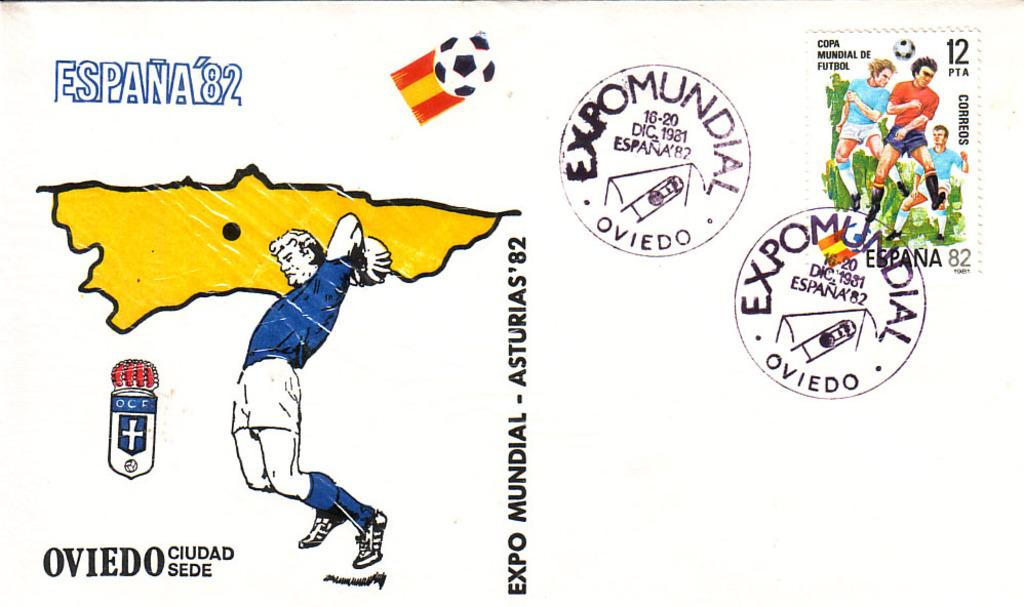What is the main object in the image? There is a poster in the image. What can be seen on the left side of the poster? There is a cartoon image of a person on the left side of the poster. What other elements are present on the poster? There are stamps, a logo, a picture of persons, and text on the poster. Can you tell me the purpose of the giraffe in the image? There is no giraffe present in the image, so it is not possible to determine its purpose. 